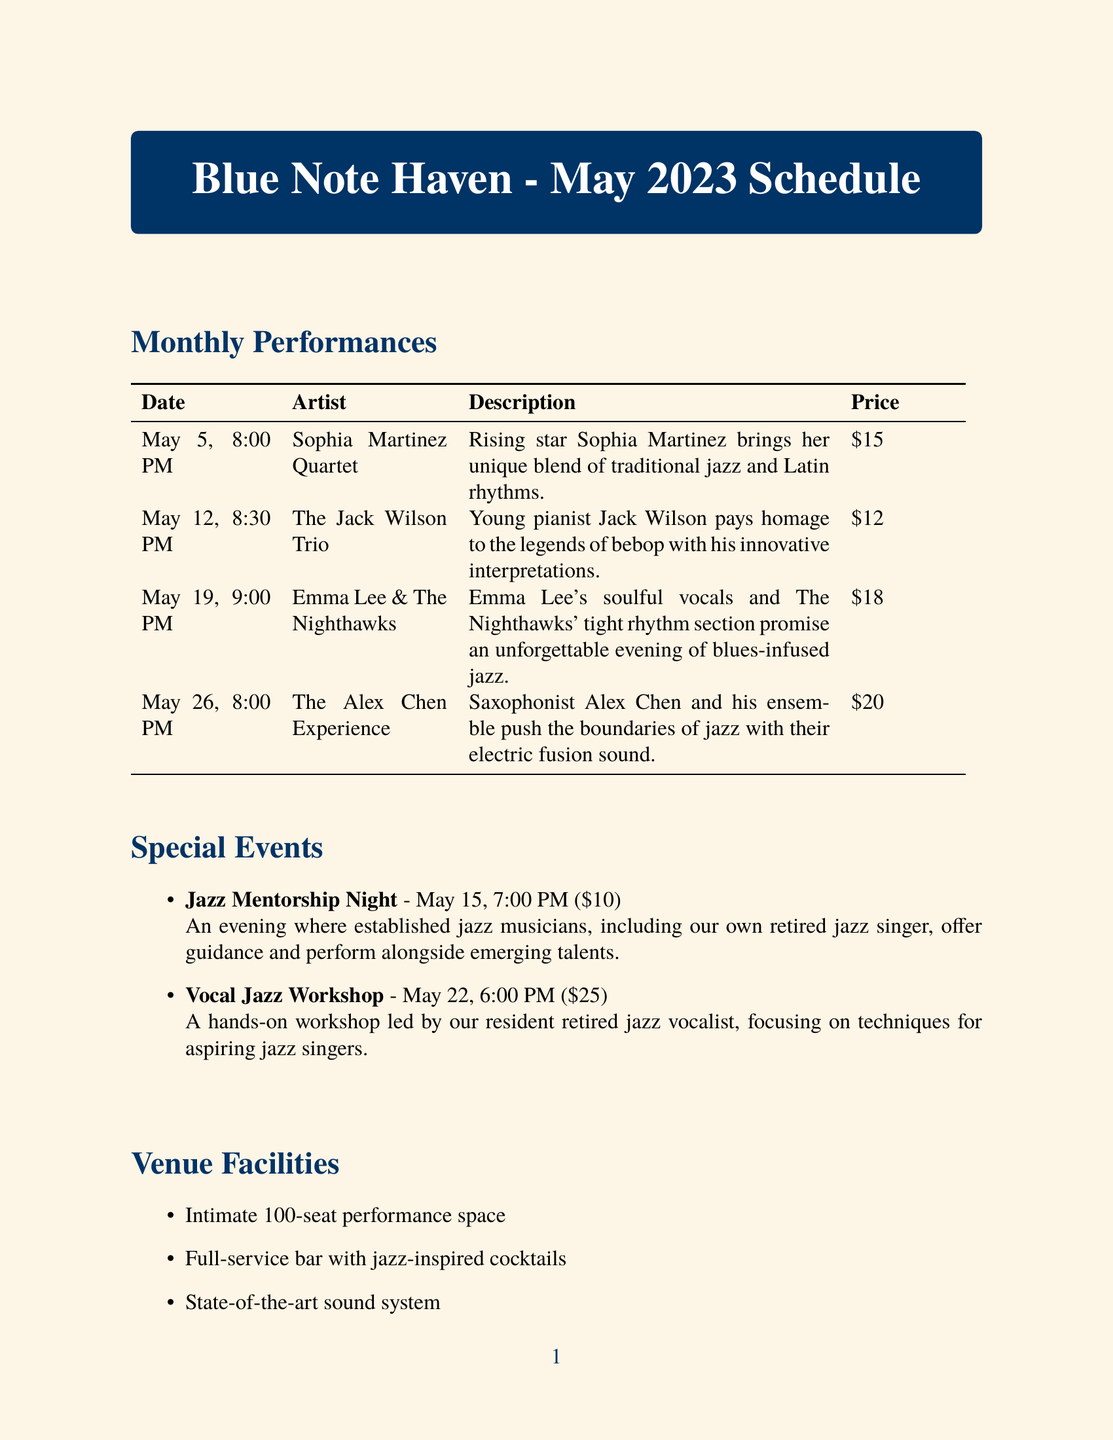What is the name of the jazz club? The name of the jazz club is specified at the beginning of the document.
Answer: Blue Note Haven When is the Jazz Mentorship Night event scheduled? The date of the Jazz Mentorship Night is stated in the special events section.
Answer: May 15, 2023 How much is the ticket price for The Alex Chen Experience performance? The ticket price is listed for each performance in the monthly performances section.
Answer: $20 What genre does Sophia Martinez Quartet perform? The genre of each artist is specified in the monthly performances section.
Answer: Latin Jazz What is the discount offered on Student Night? The description for Student Night includes specific details about the discount provided.
Answer: 50% off Which special event focuses on vocal techniques for aspiring jazz singers? The special events section outlines the focus of each event, identifying the relevant workshop.
Answer: Vocal Jazz Workshop What time does the Emma Lee & The Nighthawks performance begin? The start time for each performance is included in the monthly performances section.
Answer: 9:00 PM What is the ticket price for the Vocal Jazz Workshop? The ticket price for the Vocal Jazz Workshop is detailed in the special events section.
Answer: $25 What is the address of the jazz club? The contact information section provides the location of the jazz club.
Answer: 789 Melody Lane, Jazzville, NY 12345 